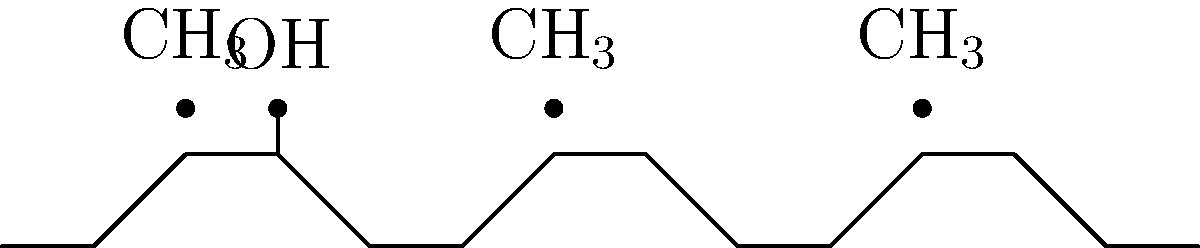The chemical structure shown above represents a common performance-enhancing steroid. Based on the structure, which of the following functional groups is present in this steroid molecule?

A) Ketone
B) Carboxyl
C) Hydroxyl
D) Amine To answer this question, we need to analyze the chemical structure of the steroid molecule:

1. The structure shows a typical four-ring system characteristic of steroids.

2. We can see several methyl (CH$_3$) groups attached to the ring system, indicated by the dots above certain carbon atoms.

3. The key feature to identify is the group attached to the third carbon of the first ring (counting from left to right).

4. This group is represented by a single line extending upwards from the ring, with a dot at the end.

5. In organic chemistry, this notation represents an OH (hydroxyl) group.

6. A hydroxyl group consists of an oxygen atom bonded to a hydrogen atom, and it's a common functional group in steroids.

7. Looking at the given options:
   A) Ketone (C=O) is not present in this structure.
   B) Carboxyl (-COOH) is not present.
   C) Hydroxyl (-OH) is present.
   D) Amine (-NH$_2$ or -NHR or -NR$_2$) is not present.

Therefore, the correct answer is that a hydroxyl group is present in this steroid molecule.
Answer: Hydroxyl 